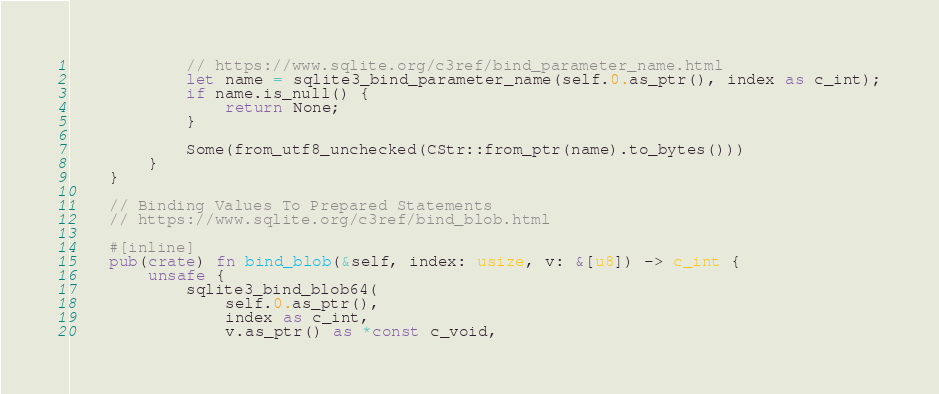Convert code to text. <code><loc_0><loc_0><loc_500><loc_500><_Rust_>            // https://www.sqlite.org/c3ref/bind_parameter_name.html
            let name = sqlite3_bind_parameter_name(self.0.as_ptr(), index as c_int);
            if name.is_null() {
                return None;
            }

            Some(from_utf8_unchecked(CStr::from_ptr(name).to_bytes()))
        }
    }

    // Binding Values To Prepared Statements
    // https://www.sqlite.org/c3ref/bind_blob.html

    #[inline]
    pub(crate) fn bind_blob(&self, index: usize, v: &[u8]) -> c_int {
        unsafe {
            sqlite3_bind_blob64(
                self.0.as_ptr(),
                index as c_int,
                v.as_ptr() as *const c_void,</code> 